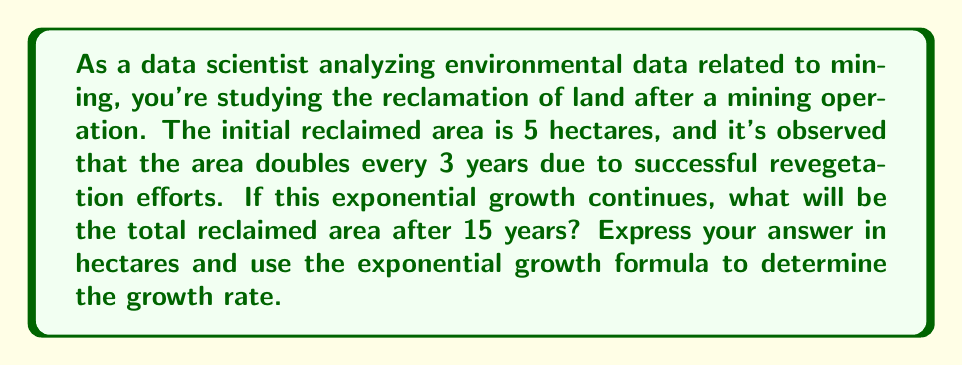Teach me how to tackle this problem. To solve this problem, we'll use the exponential growth formula:

$$A(t) = A_0 \cdot e^{rt}$$

Where:
$A(t)$ is the area at time $t$
$A_0$ is the initial area
$e$ is Euler's number (approximately 2.71828)
$r$ is the growth rate
$t$ is the time

We know that:
$A_0 = 5$ hectares
$t = 15$ years
The area doubles every 3 years

First, let's find the growth rate $r$:

1) We can use the doubling time formula: $2 = e^{3r}$
2) Taking the natural log of both sides: $\ln(2) = 3r$
3) Solving for $r$: $r = \frac{\ln(2)}{3} \approx 0.2310$

Now we can plug these values into the exponential growth formula:

$$A(15) = 5 \cdot e^{0.2310 \cdot 15}$$

$$A(15) = 5 \cdot e^{3.465}$$

$$A(15) = 5 \cdot 32$$

$$A(15) = 160$$

Therefore, after 15 years, the reclaimed area will be 160 hectares.

To verify, we can check if this result matches the doubling every 3 years:
5 hectares → 10 hectares → 20 hectares → 40 hectares → 80 hectares → 160 hectares
This confirms our calculation.
Answer: The total reclaimed area after 15 years will be 160 hectares, with an exponential growth rate of approximately 0.2310 or 23.10% per year. 